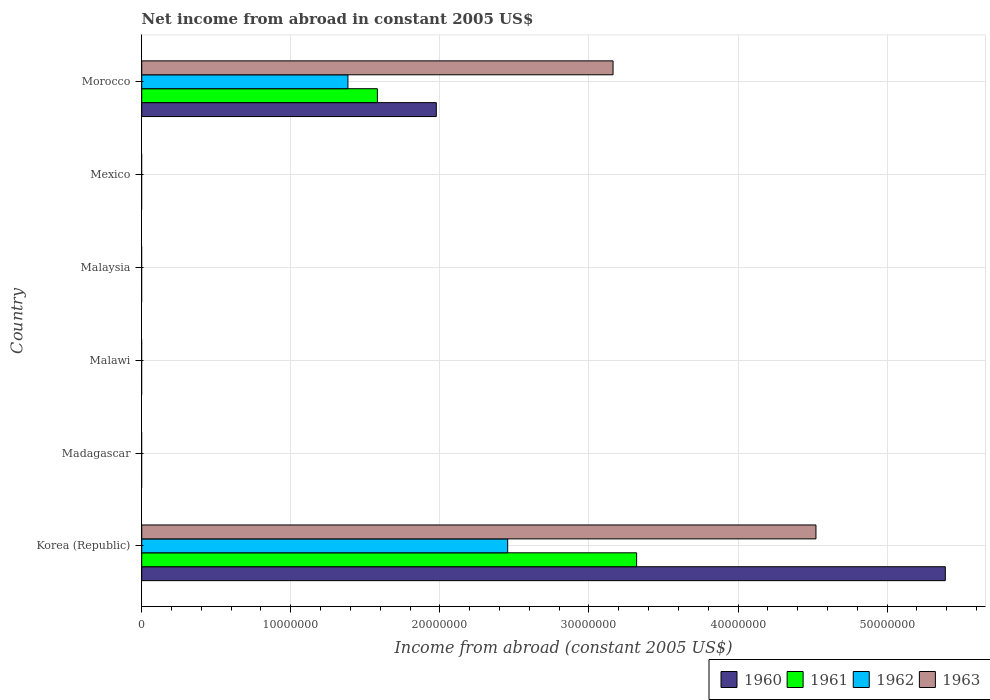Are the number of bars per tick equal to the number of legend labels?
Offer a terse response. No. How many bars are there on the 2nd tick from the bottom?
Give a very brief answer. 0. What is the label of the 3rd group of bars from the top?
Your answer should be compact. Malaysia. In how many cases, is the number of bars for a given country not equal to the number of legend labels?
Provide a short and direct response. 4. What is the net income from abroad in 1963 in Korea (Republic)?
Your response must be concise. 4.52e+07. Across all countries, what is the maximum net income from abroad in 1961?
Give a very brief answer. 3.32e+07. What is the total net income from abroad in 1960 in the graph?
Offer a very short reply. 7.37e+07. What is the difference between the net income from abroad in 1963 in Korea (Republic) and that in Morocco?
Provide a succinct answer. 1.36e+07. What is the difference between the net income from abroad in 1963 in Malawi and the net income from abroad in 1960 in Korea (Republic)?
Make the answer very short. -5.39e+07. What is the average net income from abroad in 1963 per country?
Your answer should be very brief. 1.28e+07. What is the difference between the net income from abroad in 1963 and net income from abroad in 1961 in Morocco?
Offer a terse response. 1.58e+07. Is the difference between the net income from abroad in 1963 in Korea (Republic) and Morocco greater than the difference between the net income from abroad in 1961 in Korea (Republic) and Morocco?
Make the answer very short. No. What is the difference between the highest and the lowest net income from abroad in 1962?
Your response must be concise. 2.45e+07. In how many countries, is the net income from abroad in 1961 greater than the average net income from abroad in 1961 taken over all countries?
Provide a short and direct response. 2. Is it the case that in every country, the sum of the net income from abroad in 1961 and net income from abroad in 1962 is greater than the net income from abroad in 1963?
Provide a short and direct response. No. How many countries are there in the graph?
Make the answer very short. 6. Are the values on the major ticks of X-axis written in scientific E-notation?
Ensure brevity in your answer.  No. Does the graph contain any zero values?
Make the answer very short. Yes. Does the graph contain grids?
Give a very brief answer. Yes. How are the legend labels stacked?
Your response must be concise. Horizontal. What is the title of the graph?
Keep it short and to the point. Net income from abroad in constant 2005 US$. What is the label or title of the X-axis?
Your answer should be very brief. Income from abroad (constant 2005 US$). What is the Income from abroad (constant 2005 US$) in 1960 in Korea (Republic)?
Provide a succinct answer. 5.39e+07. What is the Income from abroad (constant 2005 US$) in 1961 in Korea (Republic)?
Provide a succinct answer. 3.32e+07. What is the Income from abroad (constant 2005 US$) of 1962 in Korea (Republic)?
Give a very brief answer. 2.45e+07. What is the Income from abroad (constant 2005 US$) in 1963 in Korea (Republic)?
Your answer should be very brief. 4.52e+07. What is the Income from abroad (constant 2005 US$) in 1960 in Madagascar?
Your answer should be very brief. 0. What is the Income from abroad (constant 2005 US$) in 1960 in Malawi?
Your response must be concise. 0. What is the Income from abroad (constant 2005 US$) of 1961 in Malawi?
Your answer should be very brief. 0. What is the Income from abroad (constant 2005 US$) in 1962 in Malawi?
Provide a short and direct response. 0. What is the Income from abroad (constant 2005 US$) of 1963 in Malawi?
Provide a short and direct response. 0. What is the Income from abroad (constant 2005 US$) in 1962 in Malaysia?
Provide a succinct answer. 0. What is the Income from abroad (constant 2005 US$) in 1963 in Malaysia?
Your answer should be compact. 0. What is the Income from abroad (constant 2005 US$) in 1960 in Mexico?
Your response must be concise. 0. What is the Income from abroad (constant 2005 US$) of 1962 in Mexico?
Your answer should be very brief. 0. What is the Income from abroad (constant 2005 US$) of 1963 in Mexico?
Keep it short and to the point. 0. What is the Income from abroad (constant 2005 US$) in 1960 in Morocco?
Provide a succinct answer. 1.98e+07. What is the Income from abroad (constant 2005 US$) in 1961 in Morocco?
Provide a succinct answer. 1.58e+07. What is the Income from abroad (constant 2005 US$) in 1962 in Morocco?
Keep it short and to the point. 1.38e+07. What is the Income from abroad (constant 2005 US$) of 1963 in Morocco?
Offer a terse response. 3.16e+07. Across all countries, what is the maximum Income from abroad (constant 2005 US$) in 1960?
Provide a succinct answer. 5.39e+07. Across all countries, what is the maximum Income from abroad (constant 2005 US$) of 1961?
Make the answer very short. 3.32e+07. Across all countries, what is the maximum Income from abroad (constant 2005 US$) of 1962?
Your answer should be compact. 2.45e+07. Across all countries, what is the maximum Income from abroad (constant 2005 US$) of 1963?
Offer a terse response. 4.52e+07. Across all countries, what is the minimum Income from abroad (constant 2005 US$) of 1960?
Your response must be concise. 0. Across all countries, what is the minimum Income from abroad (constant 2005 US$) in 1961?
Keep it short and to the point. 0. What is the total Income from abroad (constant 2005 US$) in 1960 in the graph?
Ensure brevity in your answer.  7.37e+07. What is the total Income from abroad (constant 2005 US$) of 1961 in the graph?
Your answer should be compact. 4.90e+07. What is the total Income from abroad (constant 2005 US$) in 1962 in the graph?
Keep it short and to the point. 3.84e+07. What is the total Income from abroad (constant 2005 US$) in 1963 in the graph?
Offer a very short reply. 7.68e+07. What is the difference between the Income from abroad (constant 2005 US$) of 1960 in Korea (Republic) and that in Morocco?
Offer a terse response. 3.41e+07. What is the difference between the Income from abroad (constant 2005 US$) of 1961 in Korea (Republic) and that in Morocco?
Offer a very short reply. 1.74e+07. What is the difference between the Income from abroad (constant 2005 US$) of 1962 in Korea (Republic) and that in Morocco?
Provide a short and direct response. 1.07e+07. What is the difference between the Income from abroad (constant 2005 US$) of 1963 in Korea (Republic) and that in Morocco?
Offer a terse response. 1.36e+07. What is the difference between the Income from abroad (constant 2005 US$) of 1960 in Korea (Republic) and the Income from abroad (constant 2005 US$) of 1961 in Morocco?
Give a very brief answer. 3.81e+07. What is the difference between the Income from abroad (constant 2005 US$) of 1960 in Korea (Republic) and the Income from abroad (constant 2005 US$) of 1962 in Morocco?
Your answer should be compact. 4.01e+07. What is the difference between the Income from abroad (constant 2005 US$) of 1960 in Korea (Republic) and the Income from abroad (constant 2005 US$) of 1963 in Morocco?
Your answer should be compact. 2.23e+07. What is the difference between the Income from abroad (constant 2005 US$) of 1961 in Korea (Republic) and the Income from abroad (constant 2005 US$) of 1962 in Morocco?
Provide a short and direct response. 1.94e+07. What is the difference between the Income from abroad (constant 2005 US$) of 1961 in Korea (Republic) and the Income from abroad (constant 2005 US$) of 1963 in Morocco?
Offer a terse response. 1.58e+06. What is the difference between the Income from abroad (constant 2005 US$) in 1962 in Korea (Republic) and the Income from abroad (constant 2005 US$) in 1963 in Morocco?
Ensure brevity in your answer.  -7.07e+06. What is the average Income from abroad (constant 2005 US$) in 1960 per country?
Provide a succinct answer. 1.23e+07. What is the average Income from abroad (constant 2005 US$) in 1961 per country?
Provide a short and direct response. 8.17e+06. What is the average Income from abroad (constant 2005 US$) of 1962 per country?
Offer a very short reply. 6.40e+06. What is the average Income from abroad (constant 2005 US$) of 1963 per country?
Your answer should be compact. 1.28e+07. What is the difference between the Income from abroad (constant 2005 US$) in 1960 and Income from abroad (constant 2005 US$) in 1961 in Korea (Republic)?
Provide a succinct answer. 2.07e+07. What is the difference between the Income from abroad (constant 2005 US$) of 1960 and Income from abroad (constant 2005 US$) of 1962 in Korea (Republic)?
Offer a terse response. 2.94e+07. What is the difference between the Income from abroad (constant 2005 US$) of 1960 and Income from abroad (constant 2005 US$) of 1963 in Korea (Republic)?
Give a very brief answer. 8.68e+06. What is the difference between the Income from abroad (constant 2005 US$) of 1961 and Income from abroad (constant 2005 US$) of 1962 in Korea (Republic)?
Make the answer very short. 8.65e+06. What is the difference between the Income from abroad (constant 2005 US$) of 1961 and Income from abroad (constant 2005 US$) of 1963 in Korea (Republic)?
Ensure brevity in your answer.  -1.20e+07. What is the difference between the Income from abroad (constant 2005 US$) of 1962 and Income from abroad (constant 2005 US$) of 1963 in Korea (Republic)?
Your answer should be very brief. -2.07e+07. What is the difference between the Income from abroad (constant 2005 US$) in 1960 and Income from abroad (constant 2005 US$) in 1961 in Morocco?
Your answer should be very brief. 3.95e+06. What is the difference between the Income from abroad (constant 2005 US$) in 1960 and Income from abroad (constant 2005 US$) in 1962 in Morocco?
Your answer should be very brief. 5.93e+06. What is the difference between the Income from abroad (constant 2005 US$) in 1960 and Income from abroad (constant 2005 US$) in 1963 in Morocco?
Your answer should be compact. -1.19e+07. What is the difference between the Income from abroad (constant 2005 US$) in 1961 and Income from abroad (constant 2005 US$) in 1962 in Morocco?
Offer a very short reply. 1.98e+06. What is the difference between the Income from abroad (constant 2005 US$) in 1961 and Income from abroad (constant 2005 US$) in 1963 in Morocco?
Your response must be concise. -1.58e+07. What is the difference between the Income from abroad (constant 2005 US$) of 1962 and Income from abroad (constant 2005 US$) of 1963 in Morocco?
Offer a terse response. -1.78e+07. What is the ratio of the Income from abroad (constant 2005 US$) of 1960 in Korea (Republic) to that in Morocco?
Your answer should be very brief. 2.73. What is the ratio of the Income from abroad (constant 2005 US$) in 1962 in Korea (Republic) to that in Morocco?
Your answer should be very brief. 1.77. What is the ratio of the Income from abroad (constant 2005 US$) in 1963 in Korea (Republic) to that in Morocco?
Keep it short and to the point. 1.43. What is the difference between the highest and the lowest Income from abroad (constant 2005 US$) in 1960?
Keep it short and to the point. 5.39e+07. What is the difference between the highest and the lowest Income from abroad (constant 2005 US$) in 1961?
Provide a short and direct response. 3.32e+07. What is the difference between the highest and the lowest Income from abroad (constant 2005 US$) in 1962?
Your answer should be very brief. 2.45e+07. What is the difference between the highest and the lowest Income from abroad (constant 2005 US$) of 1963?
Your answer should be very brief. 4.52e+07. 